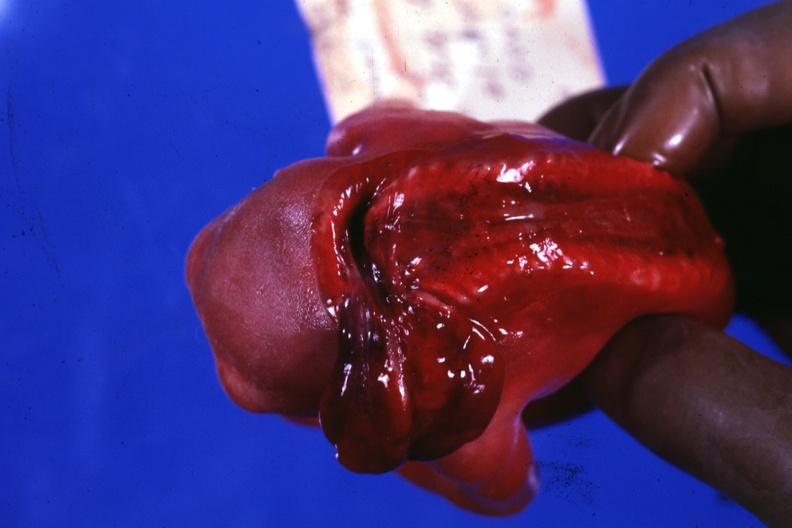s digits present?
Answer the question using a single word or phrase. No 